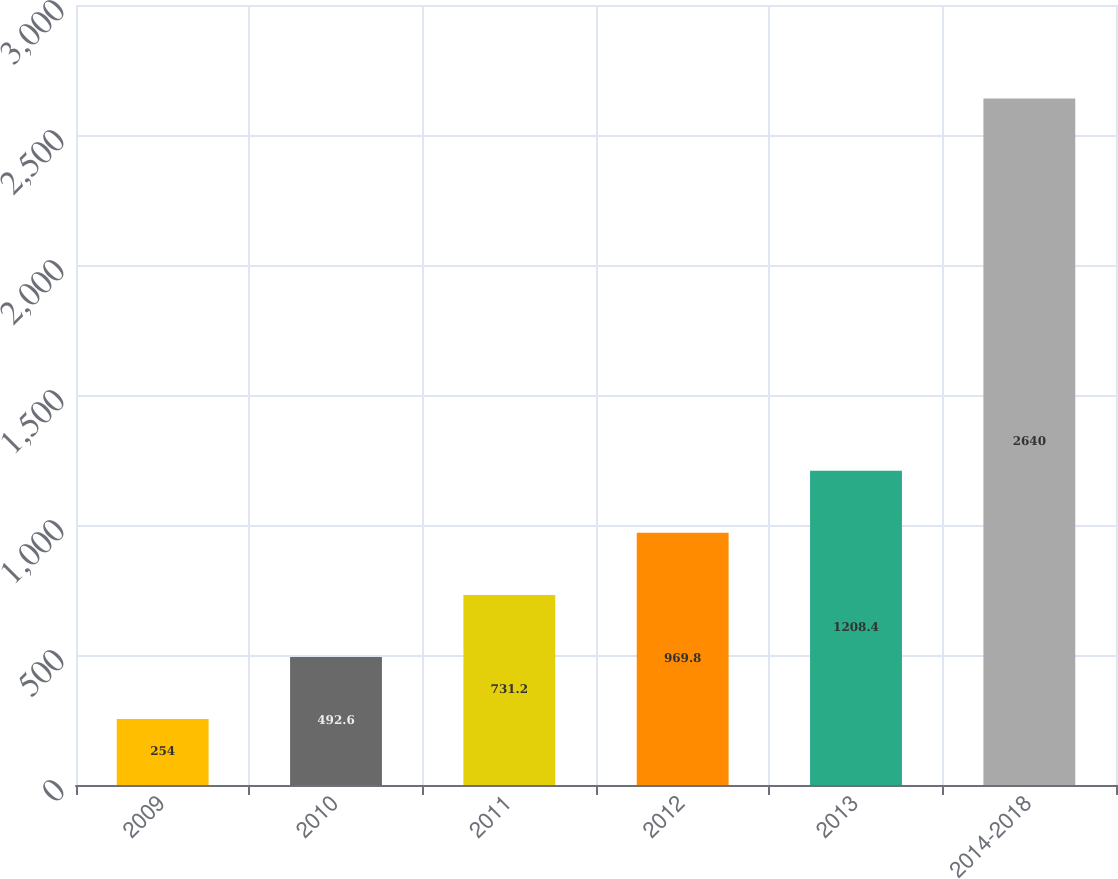<chart> <loc_0><loc_0><loc_500><loc_500><bar_chart><fcel>2009<fcel>2010<fcel>2011<fcel>2012<fcel>2013<fcel>2014-2018<nl><fcel>254<fcel>492.6<fcel>731.2<fcel>969.8<fcel>1208.4<fcel>2640<nl></chart> 